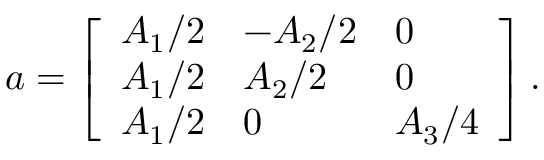<formula> <loc_0><loc_0><loc_500><loc_500>a = \left [ \begin{array} { l l l } { A _ { 1 } / 2 } & { - A _ { 2 } / 2 } & { 0 } \\ { A _ { 1 } / 2 } & { A _ { 2 } / 2 } & { 0 } \\ { A _ { 1 } / 2 } & { 0 } & { A _ { 3 } / 4 } \end{array} \right ] .</formula> 